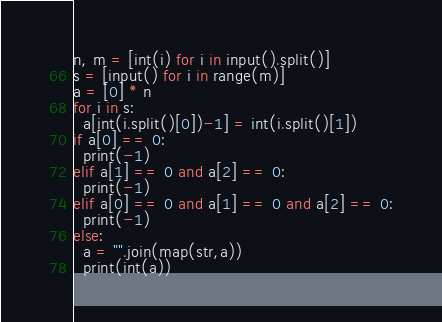<code> <loc_0><loc_0><loc_500><loc_500><_Python_>n, m = [int(i) for i in input().split()]
s = [input() for i in range(m)]
a = [0] * n
for i in s:
  a[int(i.split()[0])-1] = int(i.split()[1])
if a[0] == 0:
  print(-1)
elif a[1] == 0 and a[2] == 0:
  print(-1)
elif a[0] == 0 and a[1] == 0 and a[2] == 0:
  print(-1)
else:
  a = "".join(map(str,a))
  print(int(a))
</code> 